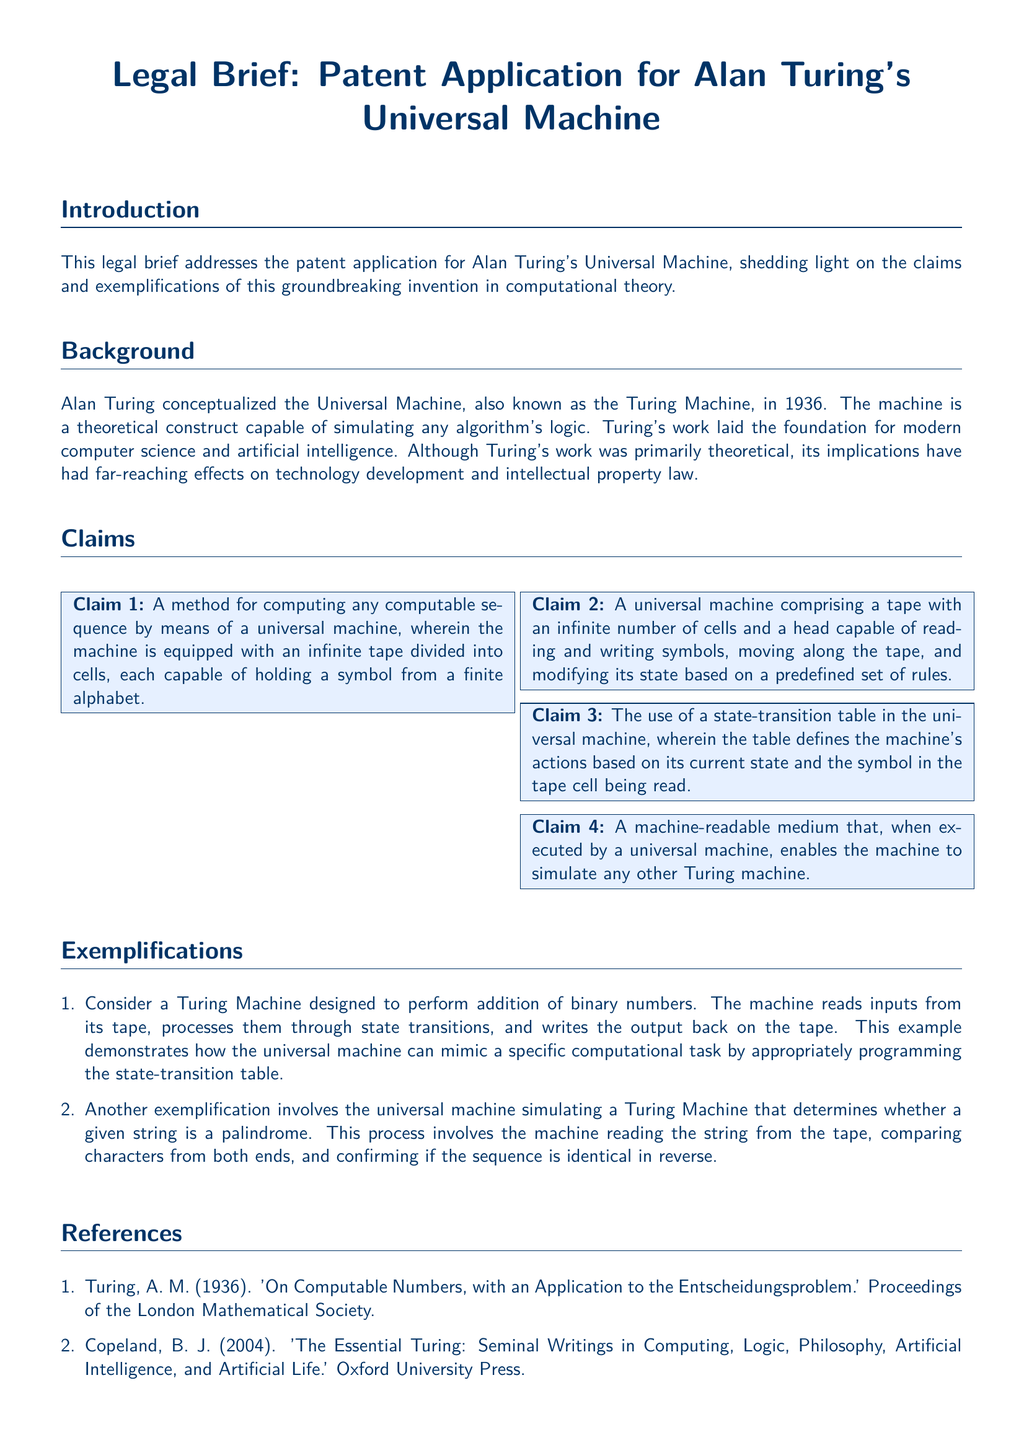What year was the Universal Machine conceptualized? The year of conceptualization is mentioned in the background section, which states Alan Turing conceptualized the Universal Machine in 1936.
Answer: 1936 How many claims are listed in the document? The claims section lists four claims regarding the Universal Machine, indicating the number of claims.
Answer: 4 What is the name of Turing's theoretical construct? The introduction section refers to the Universal Machine as Turing's theoretical construct.
Answer: Universal Machine What does the first claim describe? The first claim refers to a method for computing any computable sequence using a universal machine with an infinite tape divided into cells.
Answer: A method for computing any computable sequence What example is provided for a Turing Machine? The document gives an example of a Turing Machine designed to perform addition of binary numbers to illustrate how a universal machine can mimic a task.
Answer: Addition of binary numbers What is a key feature of the Universal Machine according to the second claim? The second claim outlines that the universal machine includes a tape with an infinite number of cells.
Answer: Tape with infinite number of cells Which publication did Turing contribute to in 1936? The references section notes that Turing's significant work from 1936 can be found in 'On Computable Numbers, with an Application to the Entscheidungsproblem.'
Answer: On Computable Numbers, with an Application to the Entscheidungsproblem What does the state-transition table do? Claim three explains that the state-transition table defines the machine's actions based on its current state and the symbol read from the tape.
Answer: Defines the machine's actions What type of document is this piece? The document is described as a legal brief that addresses a patent application for Alan Turing's Universal Machine.
Answer: Legal brief 